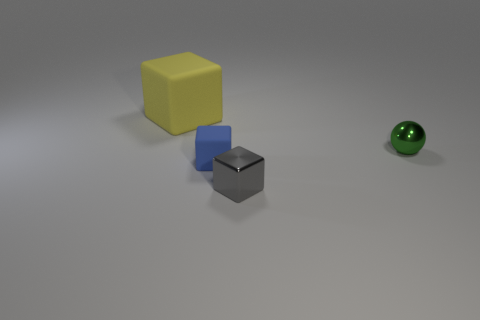Is there any other thing that is the same size as the yellow matte thing?
Your response must be concise. No. What is the shape of the green shiny thing that is the same size as the gray thing?
Offer a terse response. Sphere. Is the number of matte things less than the number of spheres?
Provide a succinct answer. No. There is a rubber thing in front of the sphere; is there a small gray object behind it?
Give a very brief answer. No. What is the shape of the small green object that is the same material as the gray cube?
Give a very brief answer. Sphere. Is there any other thing that has the same color as the sphere?
Offer a terse response. No. There is a big thing that is the same shape as the small blue object; what material is it?
Keep it short and to the point. Rubber. What number of other objects are the same size as the yellow rubber thing?
Ensure brevity in your answer.  0. There is a metallic object that is on the right side of the tiny gray object; does it have the same shape as the blue object?
Provide a succinct answer. No. How many other things are there of the same shape as the small gray object?
Your response must be concise. 2. 